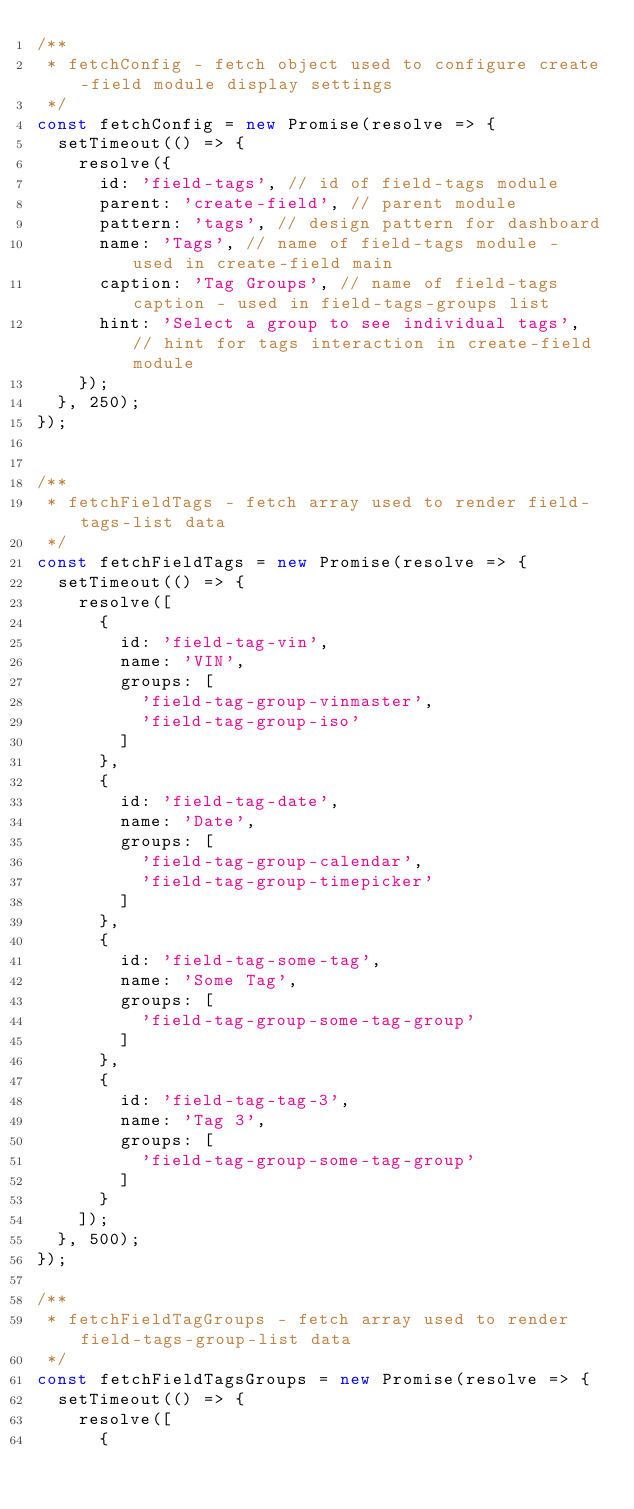<code> <loc_0><loc_0><loc_500><loc_500><_JavaScript_>/**
 * fetchConfig - fetch object used to configure create-field module display settings
 */
const fetchConfig = new Promise(resolve => {
  setTimeout(() => {
    resolve({
      id: 'field-tags', // id of field-tags module
      parent: 'create-field', // parent module
      pattern: 'tags', // design pattern for dashboard
      name: 'Tags', // name of field-tags module - used in create-field main
      caption: 'Tag Groups', // name of field-tags caption - used in field-tags-groups list
      hint: 'Select a group to see individual tags', // hint for tags interaction in create-field module
    });
  }, 250);
});


/**
 * fetchFieldTags - fetch array used to render field-tags-list data
 */
const fetchFieldTags = new Promise(resolve => {
  setTimeout(() => {
    resolve([
      {
        id: 'field-tag-vin',
        name: 'VIN',
        groups: [
          'field-tag-group-vinmaster',
          'field-tag-group-iso'
        ]
      },
      {
        id: 'field-tag-date',
        name: 'Date',
        groups: [
          'field-tag-group-calendar',
          'field-tag-group-timepicker'
        ]
      },
      {
        id: 'field-tag-some-tag',
        name: 'Some Tag',
        groups: [
          'field-tag-group-some-tag-group'
        ]
      },
      {
        id: 'field-tag-tag-3',
        name: 'Tag 3',
        groups: [
          'field-tag-group-some-tag-group'
        ]
      }
    ]);
  }, 500);
});

/**
 * fetchFieldTagGroups - fetch array used to render field-tags-group-list data
 */
const fetchFieldTagsGroups = new Promise(resolve => {
  setTimeout(() => {
    resolve([
      {</code> 